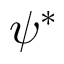Convert formula to latex. <formula><loc_0><loc_0><loc_500><loc_500>\psi ^ { * }</formula> 